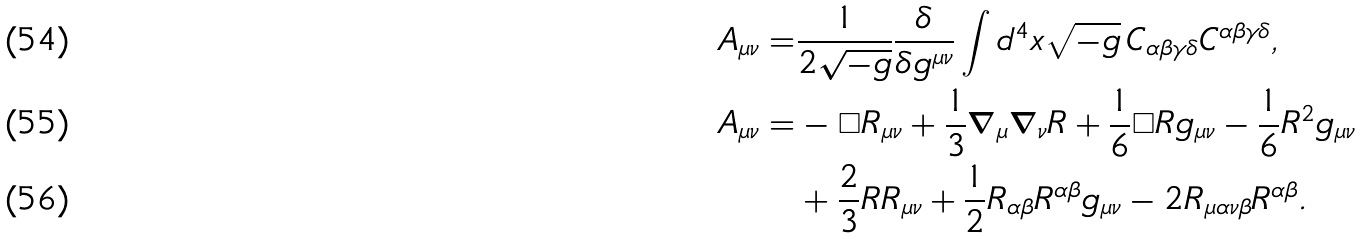<formula> <loc_0><loc_0><loc_500><loc_500>A _ { \mu \nu } = & \frac { 1 } { 2 \sqrt { - g } } \frac { \delta } { \delta g ^ { \mu \nu } } \int d ^ { 4 } x \sqrt { - g } \, C _ { \alpha \beta \gamma \delta } C ^ { \alpha \beta \gamma \delta } , \\ A _ { \mu \nu } = & - \Box R _ { \mu \nu } + \frac { 1 } { 3 } \nabla _ { \mu } \nabla _ { \nu } R + \frac { 1 } { 6 } \Box R g _ { \mu \nu } - \frac { 1 } { 6 } R ^ { 2 } g _ { \mu \nu } \\ & + \frac { 2 } { 3 } R R _ { \mu \nu } + \frac { 1 } { 2 } R _ { \alpha \beta } R ^ { \alpha \beta } g _ { \mu \nu } - 2 R _ { \mu \alpha \nu \beta } R ^ { \alpha \beta } .</formula> 